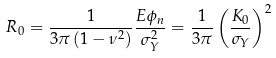<formula> <loc_0><loc_0><loc_500><loc_500>R _ { 0 } = \frac { 1 } { 3 \pi \left ( 1 - \nu ^ { 2 } \right ) } \frac { E \phi _ { n } } { \sigma _ { Y } ^ { 2 } } = \frac { 1 } { 3 \pi } \left ( \frac { K _ { 0 } } { \sigma _ { Y } } \right ) ^ { 2 }</formula> 